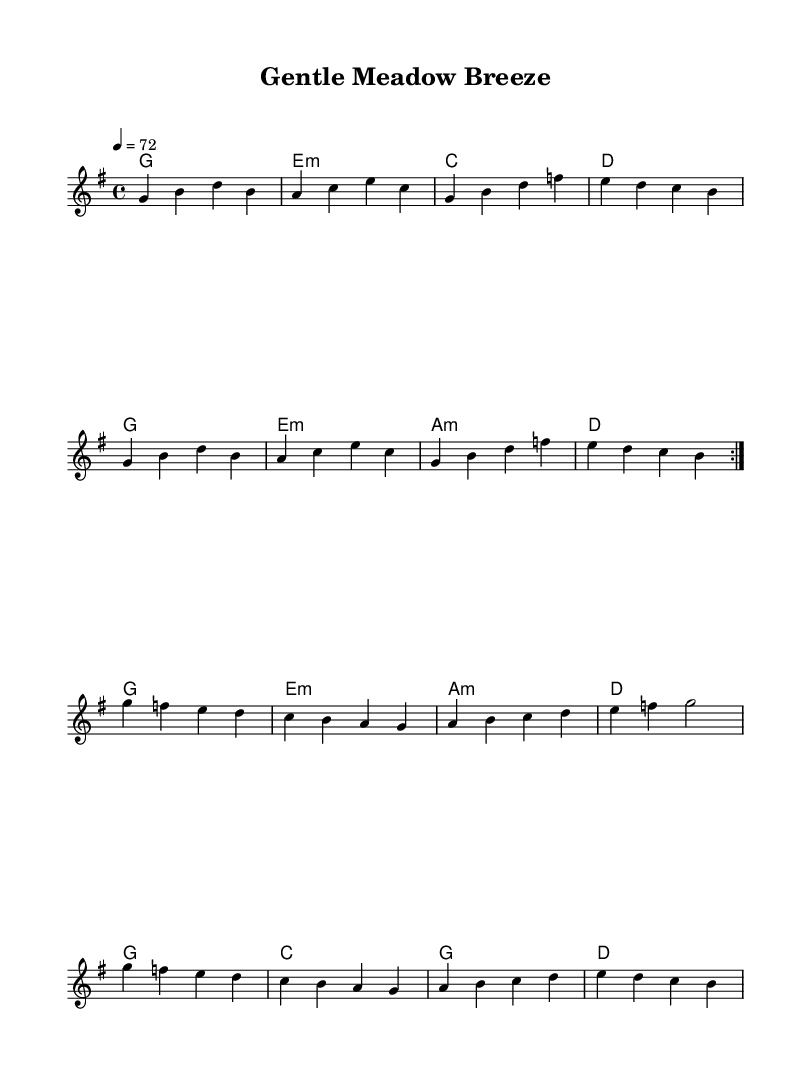What is the key signature of this music? The key signature is G major, which has one sharp (F#). This can be determined by looking at the key indicated at the beginning of the score, where the key signature is specified.
Answer: G major What is the time signature of this music? The time signature is 4/4, as indicated at the beginning of the score. This means there are four beats in each measure and a quarter note receives one beat.
Answer: 4/4 What is the tempo marking of the piece? The tempo is marked as quarter note equals 72. This indicates that each beat in the 4/4 time should be played at a speed of 72 beats per minute.
Answer: 72 How many measures are repeated in the melody section? The melody section has 8 measures that are repeated twice, indicated by the repeat signs for the volta (first and second endings).
Answer: 8 What is the first chord played in this piece? The first chord played is G major. This can be found in the chord section at the beginning of the score, and it establishes the harmonic foundation of the piece.
Answer: G What is the final note of the melody? The final note of the melody is B, which is the last note in the last measure of the repeated section. This note concludes the melodic line and ties back into the harmonic progression.
Answer: B Is the harmony section using any minor chords? Yes, the harmony section includes minor chords such as E minor and A minor. These can be identified in the chord mode section of the score, where the minor chords use the lower case 'm' notation.
Answer: Yes 